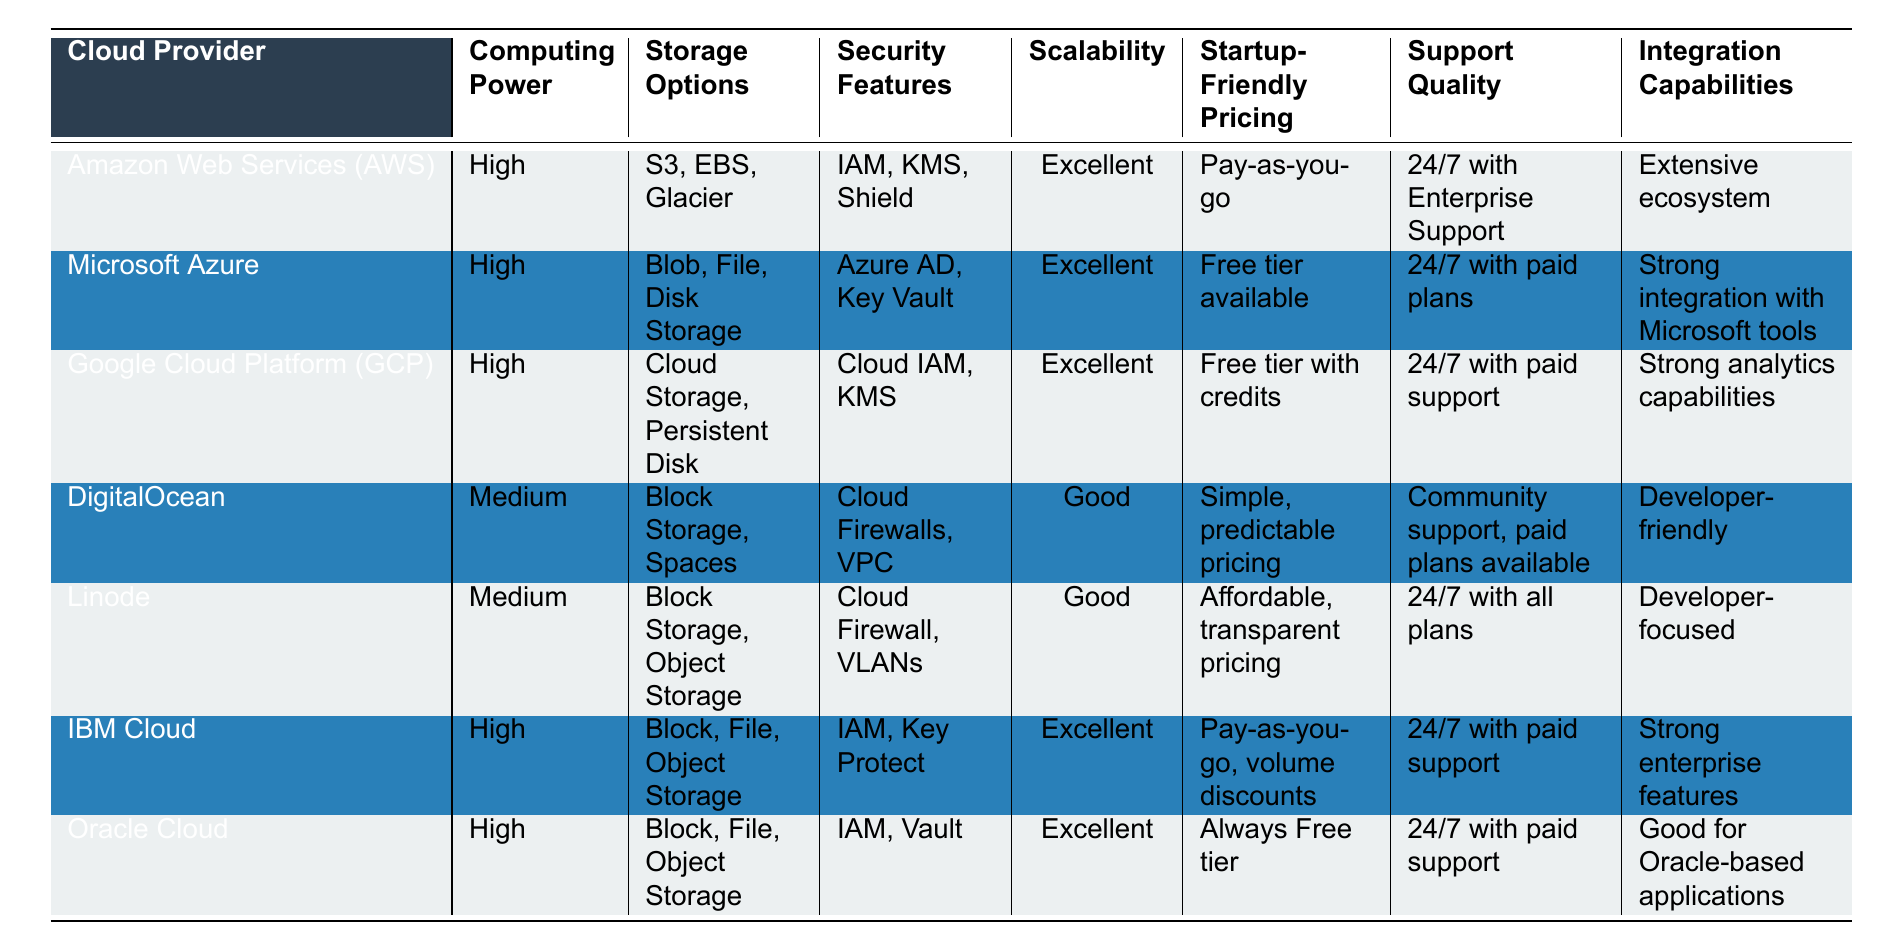What is the startup-friendly pricing option for AWS? According to the table, AWS offers a "Pay-as-you-go" pricing model.
Answer: Pay-as-you-go Which cloud provider has the best scalability? All providers listed have "Excellent" scalability except for DigitalOcean and Linode, which have "Good" scalability.
Answer: AWS, Microsoft Azure, GCP, IBM Cloud, Oracle Cloud Does DigitalOcean offer enterprise support? The table indicates that DigitalOcean provides "Community support, paid plans available," but does not mention enterprise support specifically.
Answer: No How many cloud providers offer High computing power? By counting the rows in the table, AWS, Microsoft Azure, GCP, IBM Cloud, and Oracle Cloud are categorized as "High" computing power, which makes a total of five.
Answer: 5 What are the security features of Google Cloud Platform? The table shows that Google Cloud Platform (GCP) includes "Cloud IAM, KMS" as its security features.
Answer: Cloud IAM, KMS Which cloud providers have excellent security features? The providers listed with "Excellent" security features are AWS, Microsoft Azure, GCP, IBM Cloud, and Oracle Cloud.
Answer: AWS, Microsoft Azure, GCP, IBM Cloud, Oracle Cloud Does any cloud provider offer a free tier? According to the table, both Microsoft Azure and Oracle Cloud offer a free tier.
Answer: Yes Which cloud provider is noted for strong analytics capabilities? The table indicates that Google Cloud Platform (GCP) is recognized for having "Strong analytics capabilities."
Answer: Google Cloud Platform (GCP) What is the average computing power rating for the listed providers? There are three "High" ratings (AWS, Azure, GCP, IBM, Oracle) and three "Medium" ratings (DigitalOcean, Linode). To get the average, we can say it's slightly better skewed towards high power. The average is also represented as more providers on the high side.
Answer: Higher than Medium Which provider has the best support quality? The table has AWS providing "24/7 with Enterprise Support," which is the most comprehensive support tier listed; however, IBM and Oracle also have 24/7 support.
Answer: AWS, IBM Cloud, Oracle Cloud 